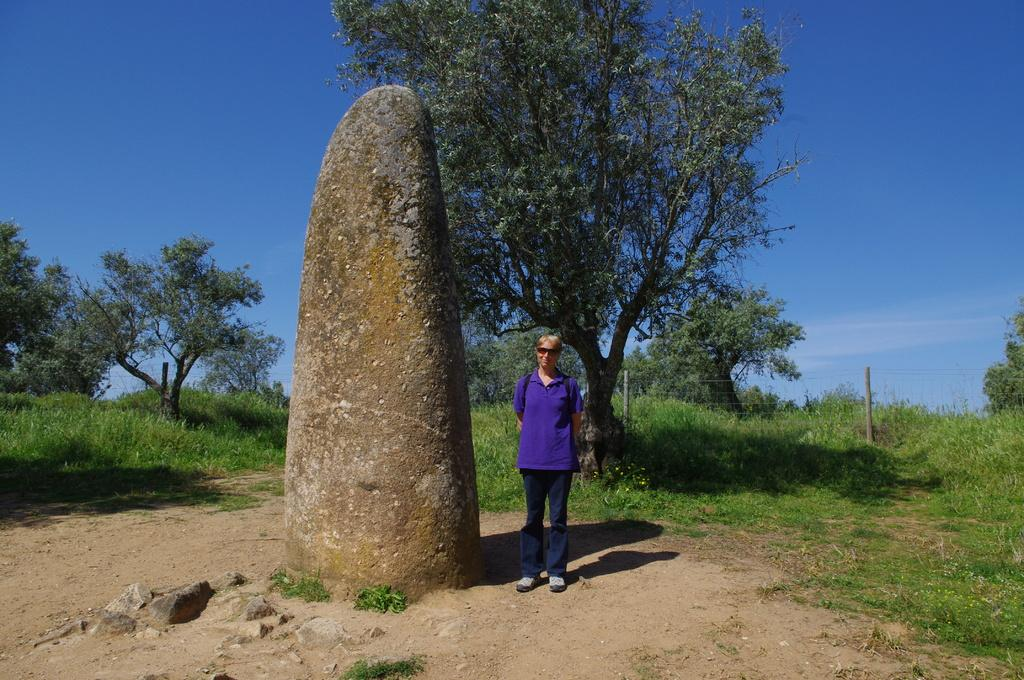Who is in the picture? There is a woman in the picture. What is the woman doing in the picture? The woman is standing. What is the woman wearing in the picture? The woman is wearing a purple shirt. What is located beside the woman in the picture? There is a rock beside the woman. What type of vegetation can be seen in the picture? There are trees in the picture. What is the condition of the sky in the picture? The sky is clear in the picture. What type of committee is meeting in the picture? There is no committee present in the image; it features a woman standing beside a rock with trees and a clear sky in the background. Can you tell me how many cats are visible in the picture? There are no cats present in the image. 